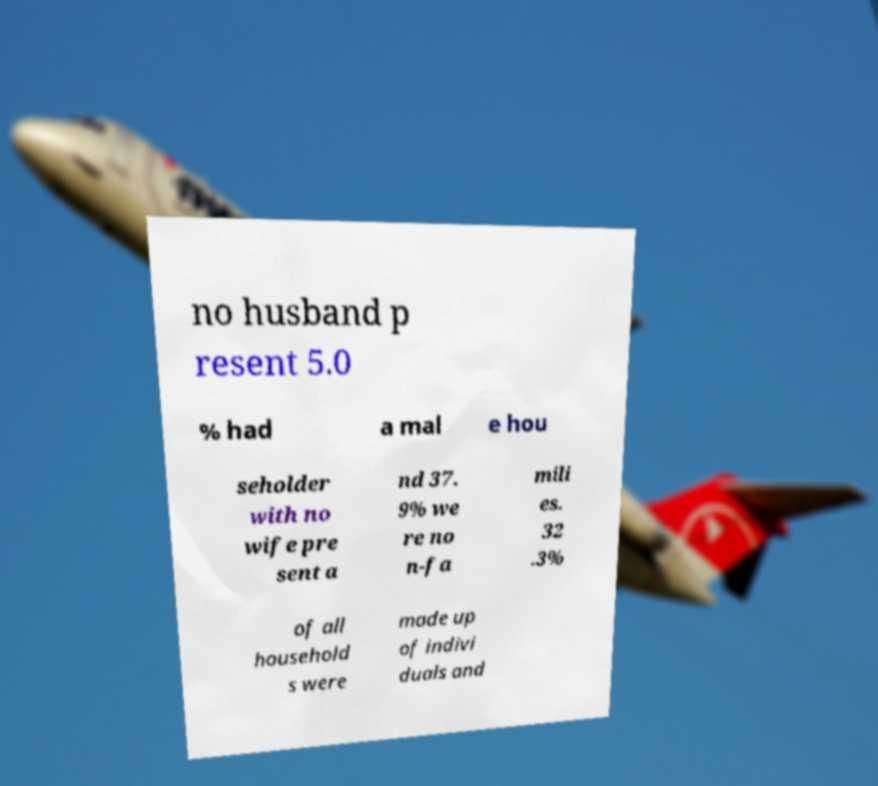What messages or text are displayed in this image? I need them in a readable, typed format. no husband p resent 5.0 % had a mal e hou seholder with no wife pre sent a nd 37. 9% we re no n-fa mili es. 32 .3% of all household s were made up of indivi duals and 